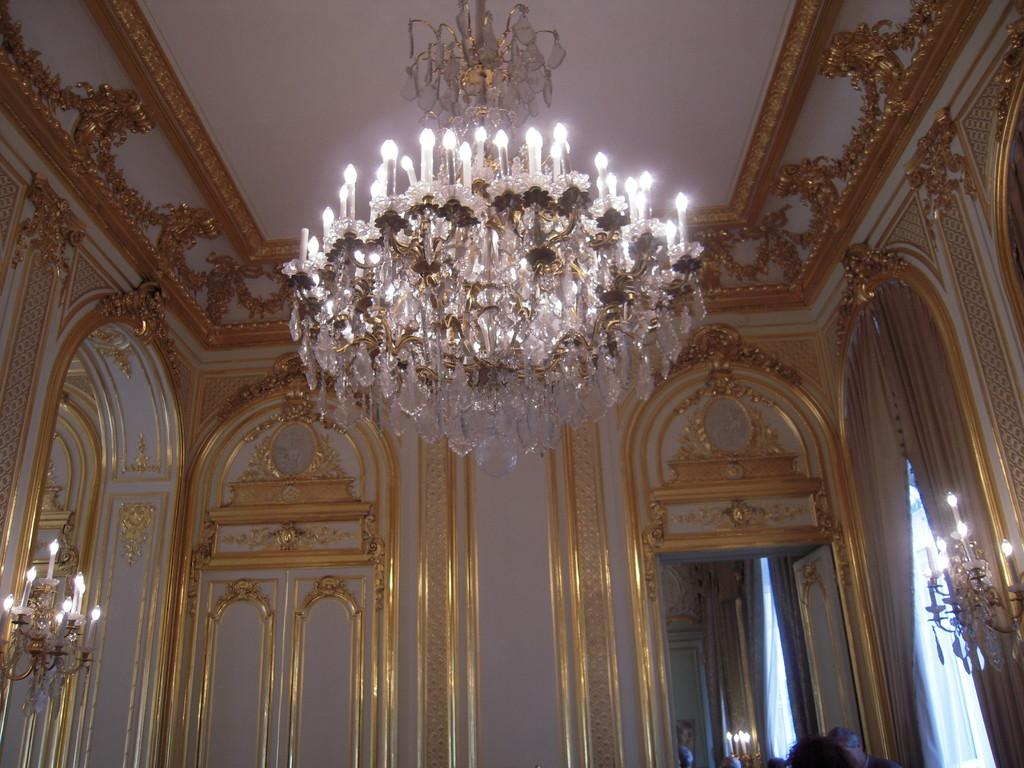What type of lighting fixture is present in the image? There is a chandelier in the image. What type of architectural feature can be seen in the image? There is a wall in the image. What type of entryway is present in the image? There is a door in the image. What type of window treatment is present in the image? There are curtains in the image. What is the source of light in the image? There is light visible in the image. What hobbies are the curtains engaged in within the image? Curtains do not engage in hobbies, as they are inanimate objects. What scale is the chandelier depicted on in the image? The scale of the chandelier in the image cannot be determined from the image alone. 